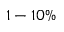<formula> <loc_0><loc_0><loc_500><loc_500>1 - 1 0 \%</formula> 